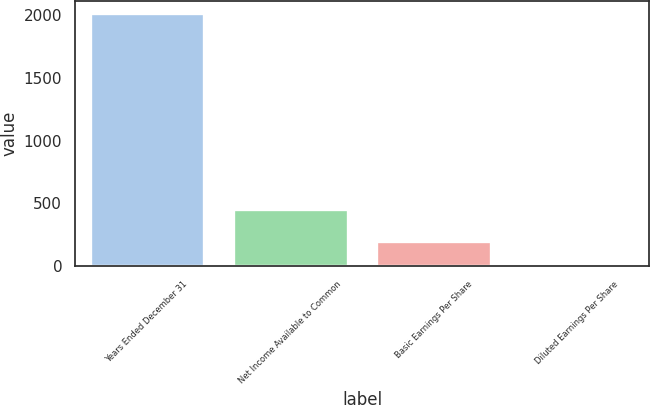Convert chart to OTSL. <chart><loc_0><loc_0><loc_500><loc_500><bar_chart><fcel>Years Ended December 31<fcel>Net Income Available to Common<fcel>Basic Earnings Per Share<fcel>Diluted Earnings Per Share<nl><fcel>2013<fcel>452<fcel>202.79<fcel>1.66<nl></chart> 